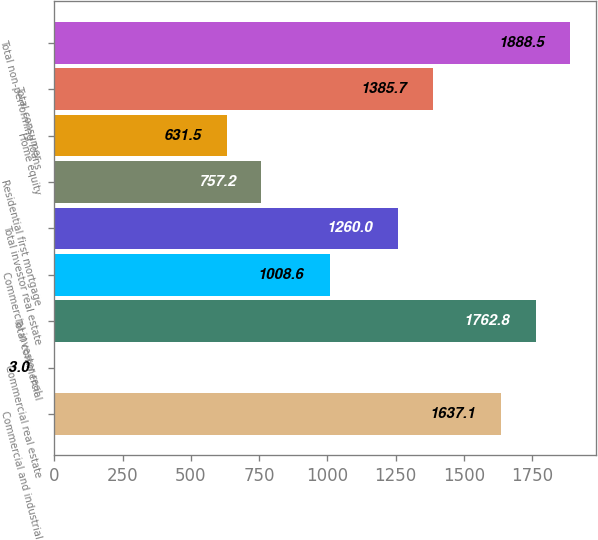Convert chart. <chart><loc_0><loc_0><loc_500><loc_500><bar_chart><fcel>Commercial and industrial<fcel>Commercial real estate<fcel>Total commercial<fcel>Commercial investor real<fcel>Total investor real estate<fcel>Residential first mortgage<fcel>Home equity<fcel>Total consumer<fcel>Total non-performing loans<nl><fcel>1637.1<fcel>3<fcel>1762.8<fcel>1008.6<fcel>1260<fcel>757.2<fcel>631.5<fcel>1385.7<fcel>1888.5<nl></chart> 